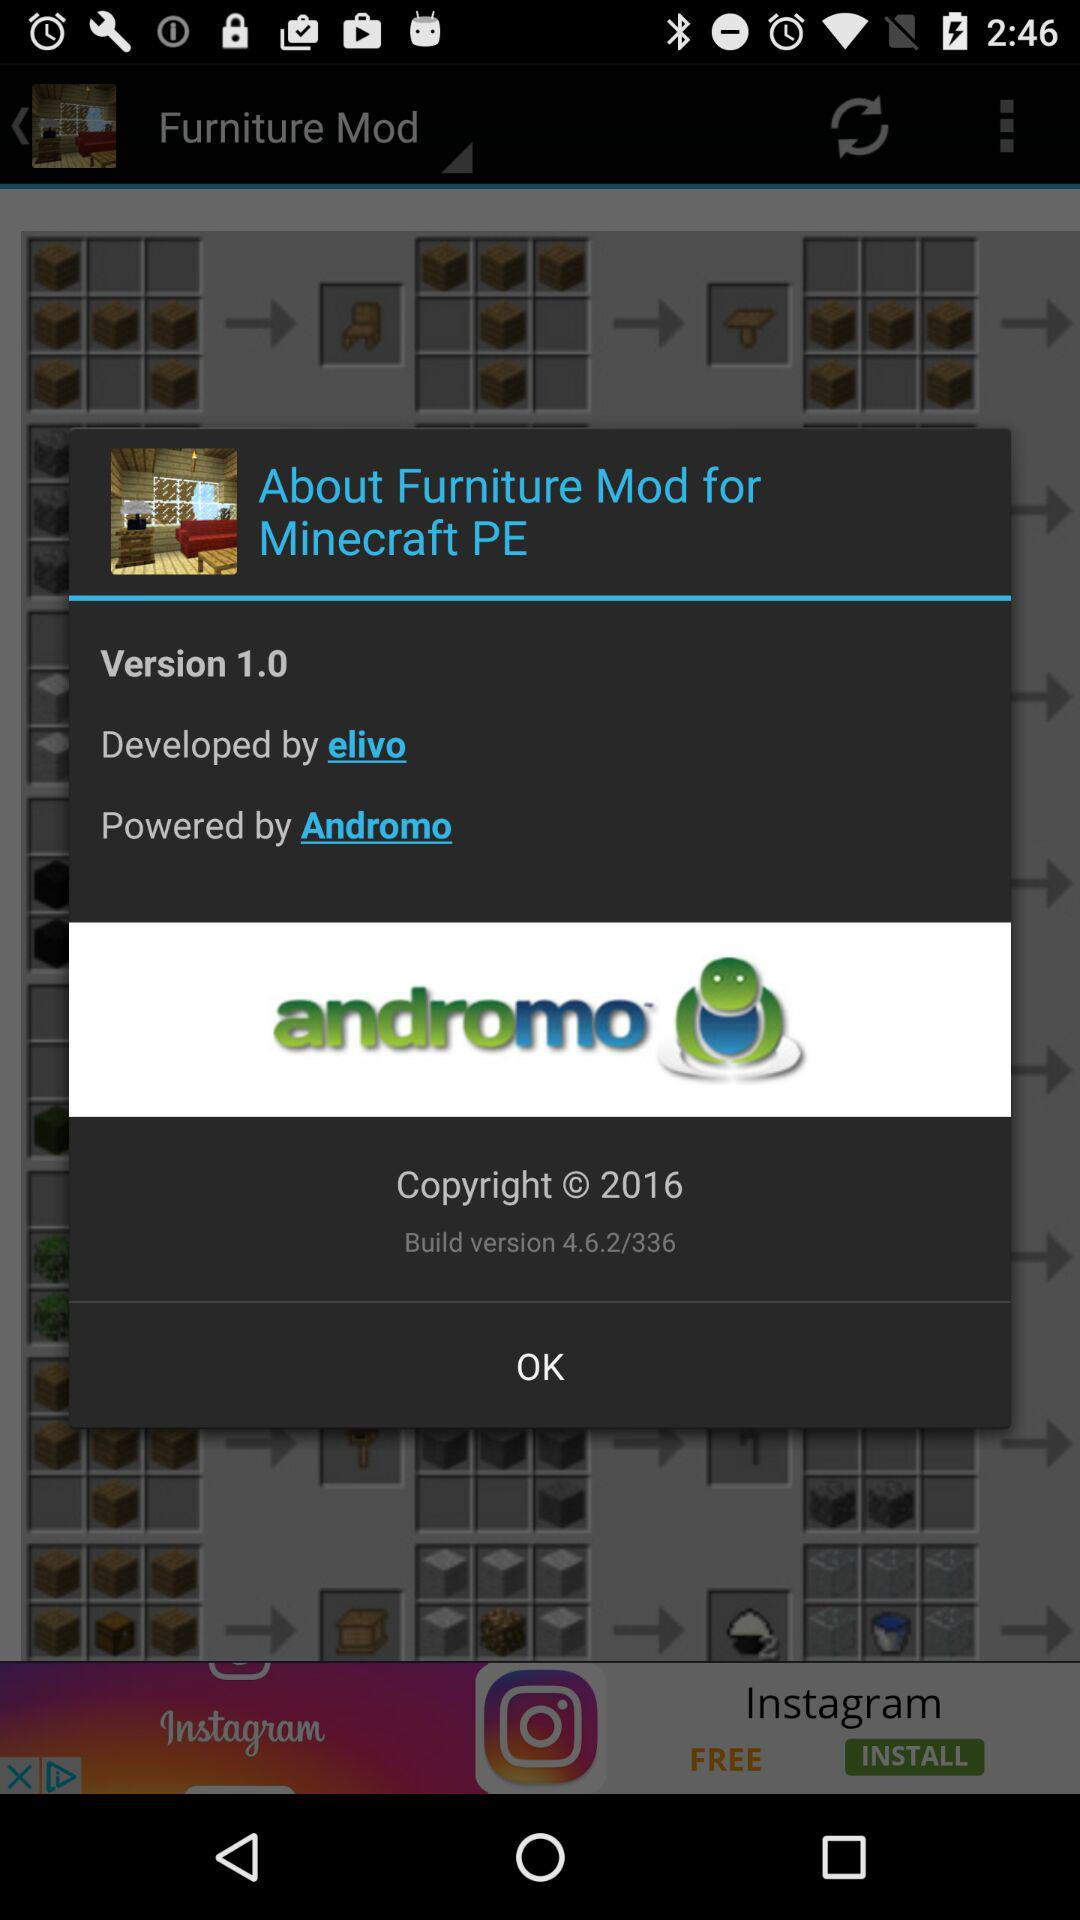What is the version? The version is 1.0. 